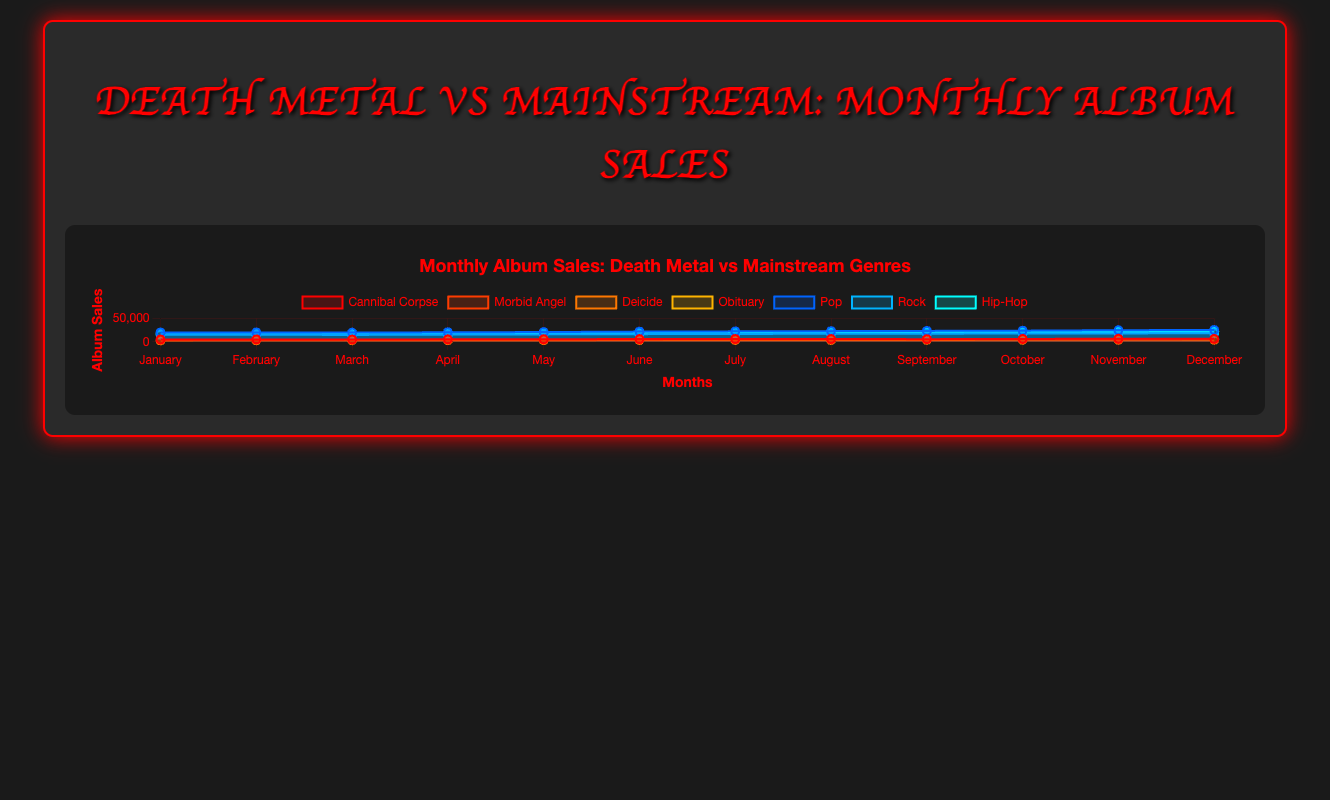What is the total album sales for Cannibal Corpse over the year? To find the total album sales for Cannibal Corpse, sum up the monthly sales: 5000 + 5200 + 4900 + 5300 + 5600 + 5900 + 6100 + 6000 + 5700 + 6200 + 6500 + 6300 = 68700
Answer: 68700 Which genre has the highest album sales in July? Compare the album sales of all bands/genres listed for July. Death Metal bands: Cannibal Corpse (6100), Morbid Angel (5300), Deicide (3800), Obituary (4300). Mainstream genres: Pop (22500), Rock (17000), Hip-Hop (20000). Hip-Hop has the highest sales in July with 20000.
Answer: Hip-Hop Is the album sales trend for Morbid Angel increasing, decreasing, or fluctuating throughout the year? Observing the line for Morbid Angel, their sales increase consistently without any drops from January (4500) to December (5800).
Answer: Increasing How do the sales of Pop music in May compare to Rock music in May? In May, Pop music has 21000 sales, and Rock music has 16000 sales. Pop sales are higher.
Answer: Pop > Rock Calculate the average monthly sales for Deicide. Sum the monthly sales for Deicide and divide by 12. Total sales: 3000 + 3200 + 3300 + 3400 + 3500 + 3700 + 3800 + 3900 + 4100 + 4200 + 4300 + 4400 = 44800. Average sales = 44800 / 12 = 3733.33
Answer: 3733.33 Which band has the least variability in their monthly sales? To determine variability, observe the fluctuation range of each band's sales throughout the year. Cannibal Corpse (4900-6500), Morbid Angel (4500-5800), Deicide (3000-4400), Obituary (3700-4800). Morbid Angel shows the least variability with a range of 1300.
Answer: Morbid Angel Compare the trend of album sales between Hip-Hop and Death Metal bands altogether. Hip-Hop shows a consistently increasing trend from 18000 in January to 22500 in December. Death Metal bands show individual fluctuations and variations, with both increasing and decreasing trends over the months.
Answer: Hip-Hop Increasing, Death Metal Fluctuating In December, which genre's album sales are closest to 6000? Check December sales: Cannibal Corpse (6300), Morbid Angel (5800), Deicide (4400), Obituary (4800), Pop (25500), Rock (18500), Hip-Hop (22500). Morbid Angel’s sales are the closest to 6000 at 5800.
Answer: Morbid Angel What is the combined album sales of all Death Metal bands in November? Sum the individual November sales of Death Metal bands: Cannibal Corpse (6500) + Morbid Angel (5700) + Deicide (4300) + Obituary (4700) = 21200
Answer: 21200 In which month did Cannibal Corpse have their maximum album sales, and what is the value? Observing the sales data for Cannibal Corpse, the maximum sales occurred in November, with a value of 6500.
Answer: November, 6500 